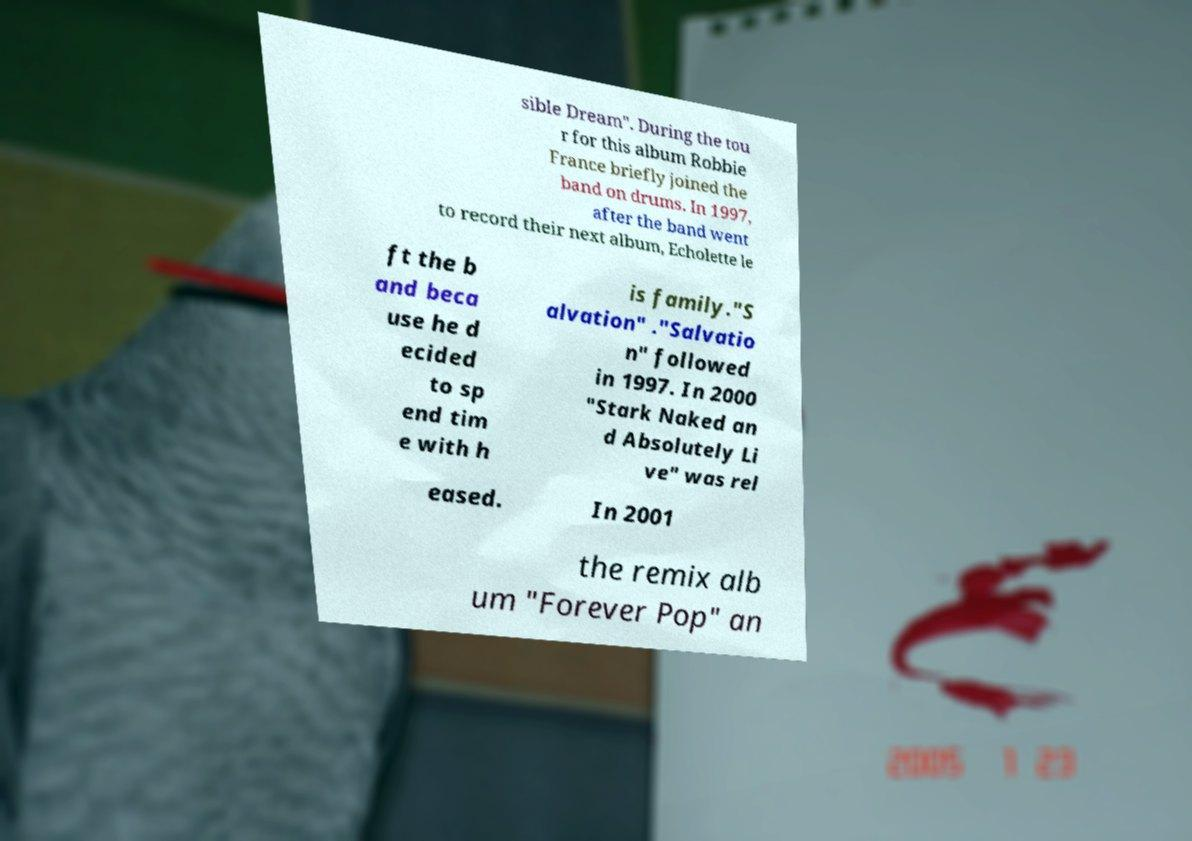I need the written content from this picture converted into text. Can you do that? sible Dream". During the tou r for this album Robbie France briefly joined the band on drums. In 1997, after the band went to record their next album, Echolette le ft the b and beca use he d ecided to sp end tim e with h is family."S alvation" ."Salvatio n" followed in 1997. In 2000 "Stark Naked an d Absolutely Li ve" was rel eased. In 2001 the remix alb um "Forever Pop" an 